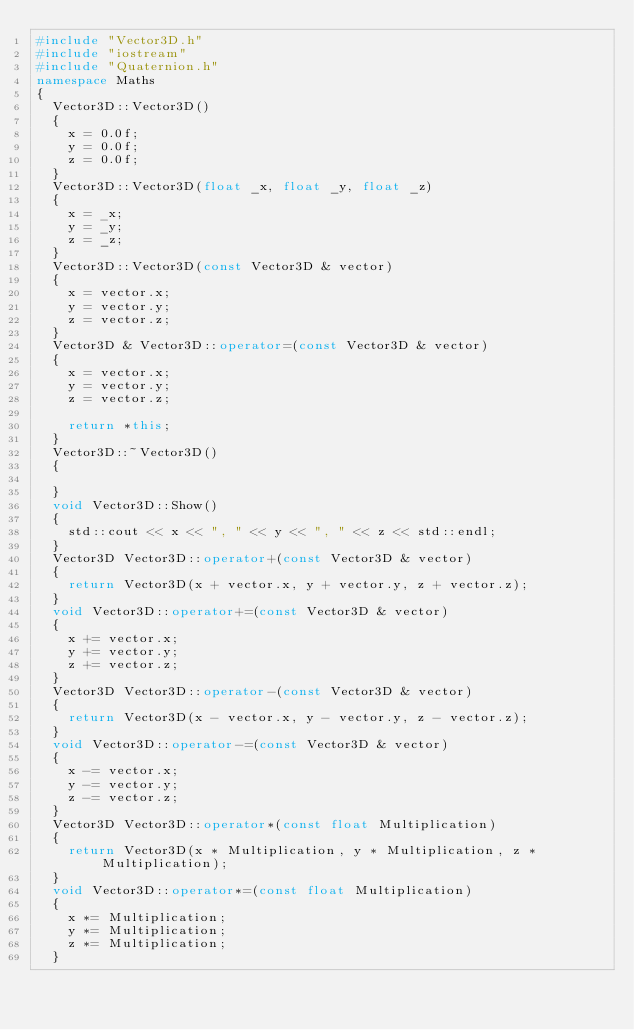<code> <loc_0><loc_0><loc_500><loc_500><_C++_>#include "Vector3D.h"
#include "iostream"
#include "Quaternion.h"
namespace Maths
{
	Vector3D::Vector3D()
	{
		x = 0.0f;
		y = 0.0f;
		z = 0.0f;
	}
	Vector3D::Vector3D(float _x, float _y, float _z)
	{
		x = _x;
		y = _y;
		z = _z;
	}
	Vector3D::Vector3D(const Vector3D & vector)
	{
		x = vector.x;
		y = vector.y;
		z = vector.z;
	}
	Vector3D & Vector3D::operator=(const Vector3D & vector)
	{
		x = vector.x;
		y = vector.y;
		z = vector.z;

		return *this;
	}
	Vector3D::~Vector3D()
	{

	}
	void Vector3D::Show()
	{
		std::cout << x << ", " << y << ", " << z << std::endl;
	}
	Vector3D Vector3D::operator+(const Vector3D & vector)
	{
		return Vector3D(x + vector.x, y + vector.y, z + vector.z);
	}
	void Vector3D::operator+=(const Vector3D & vector)
	{
		x += vector.x;
		y += vector.y;
		z += vector.z;
	}
	Vector3D Vector3D::operator-(const Vector3D & vector)
	{
		return Vector3D(x - vector.x, y - vector.y, z - vector.z);
	}
	void Vector3D::operator-=(const Vector3D & vector)
	{
		x -= vector.x;
		y -= vector.y;
		z -= vector.z;
	}
	Vector3D Vector3D::operator*(const float Multiplication)
	{
		return Vector3D(x * Multiplication, y * Multiplication, z * Multiplication);
	}
	void Vector3D::operator*=(const float Multiplication)
	{
		x *= Multiplication;
		y *= Multiplication;
		z *= Multiplication;
	}</code> 